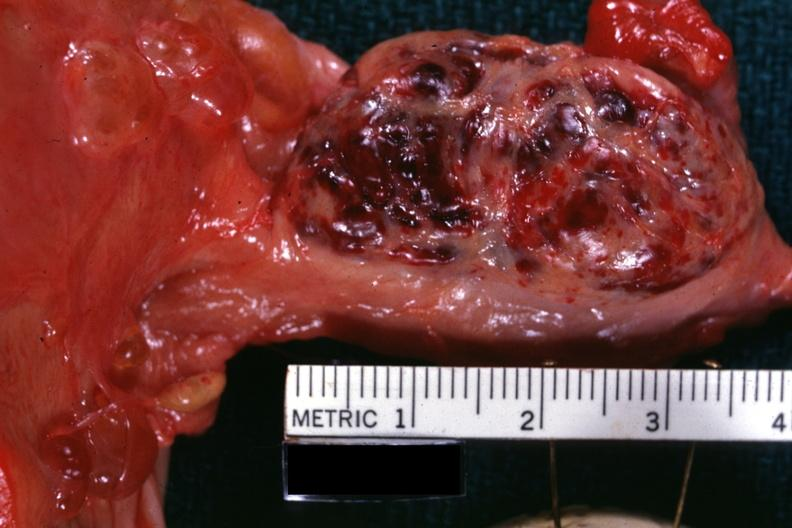s this a corpus luteum from photo?
Answer the question using a single word or phrase. Yes 